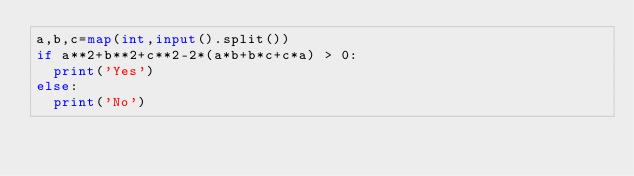<code> <loc_0><loc_0><loc_500><loc_500><_Python_>a,b,c=map(int,input().split())
if a**2+b**2+c**2-2*(a*b+b*c+c*a) > 0:
  print('Yes')
else:
  print('No')</code> 